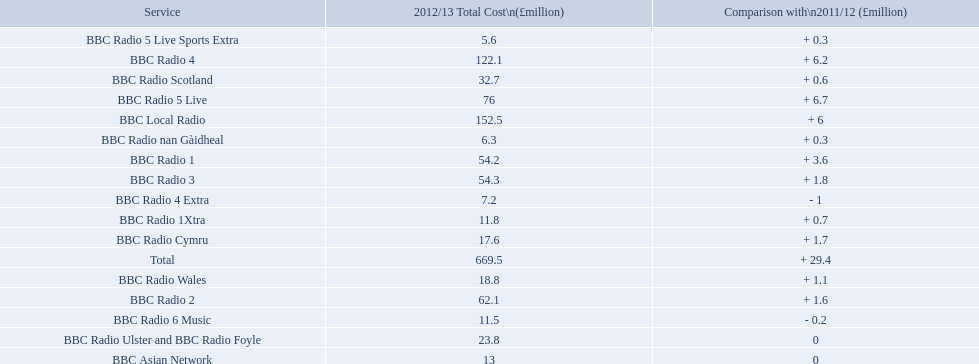Which services are there for bbc radio? BBC Radio 1, BBC Radio 1Xtra, BBC Radio 2, BBC Radio 3, BBC Radio 4, BBC Radio 4 Extra, BBC Radio 5 Live, BBC Radio 5 Live Sports Extra, BBC Radio 6 Music, BBC Asian Network, BBC Local Radio, BBC Radio Scotland, BBC Radio nan Gàidheal, BBC Radio Wales, BBC Radio Cymru, BBC Radio Ulster and BBC Radio Foyle. Of those which one had the highest cost? BBC Local Radio. 